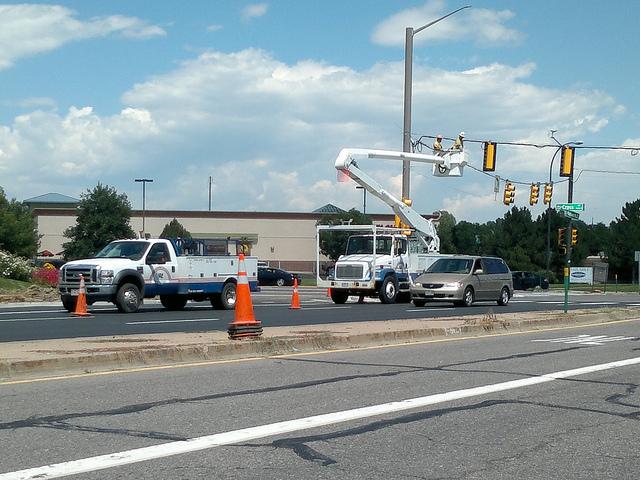Which trucks are these?
Be succinct. Utility. How high does the cherry picker bucket go?
Keep it brief. 100 feet. Are there any cars on the road?
Keep it brief. Yes. What number or orange cones are on the side of the road?
Short answer required. 4. Is the street empty?
Concise answer only. No. What color is the car?
Write a very short answer. Silver. What color is the truck?
Concise answer only. White. Is the road busy?
Quick response, please. No. Are the men fixing the stoplights?
Write a very short answer. Yes. How many men are in the cherry picker bucket?
Give a very brief answer. 2. 